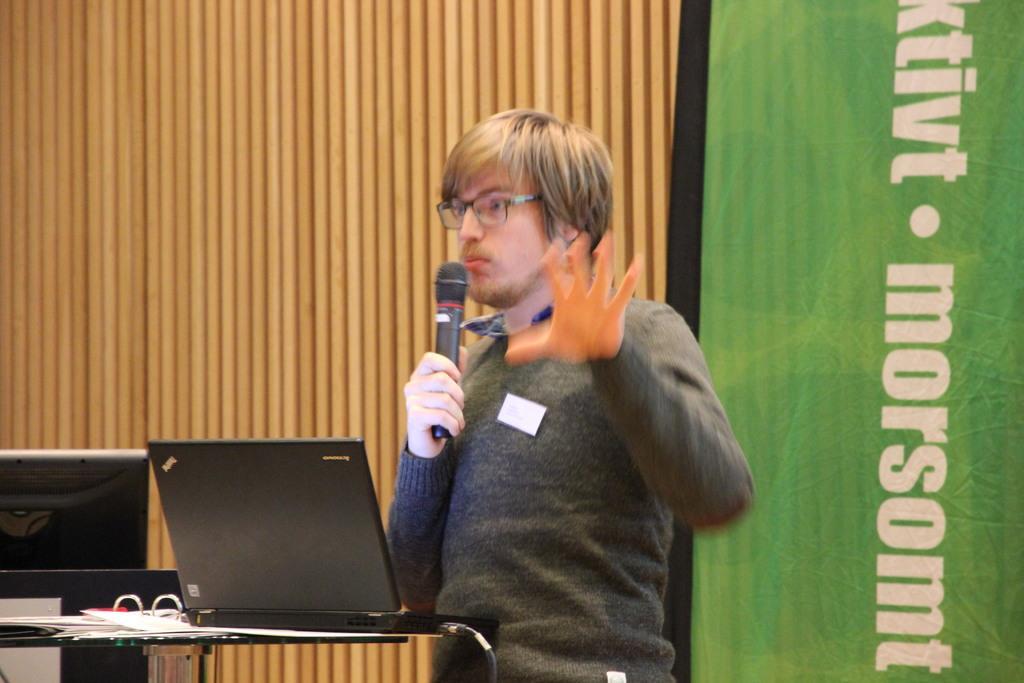Could you give a brief overview of what you see in this image? In the middle, I can see a person is holding a mike in hand is standing in front of a table on which laptops, wires, books are there. In the background, I can see a wall and a text. This image is taken may be in a hall. 